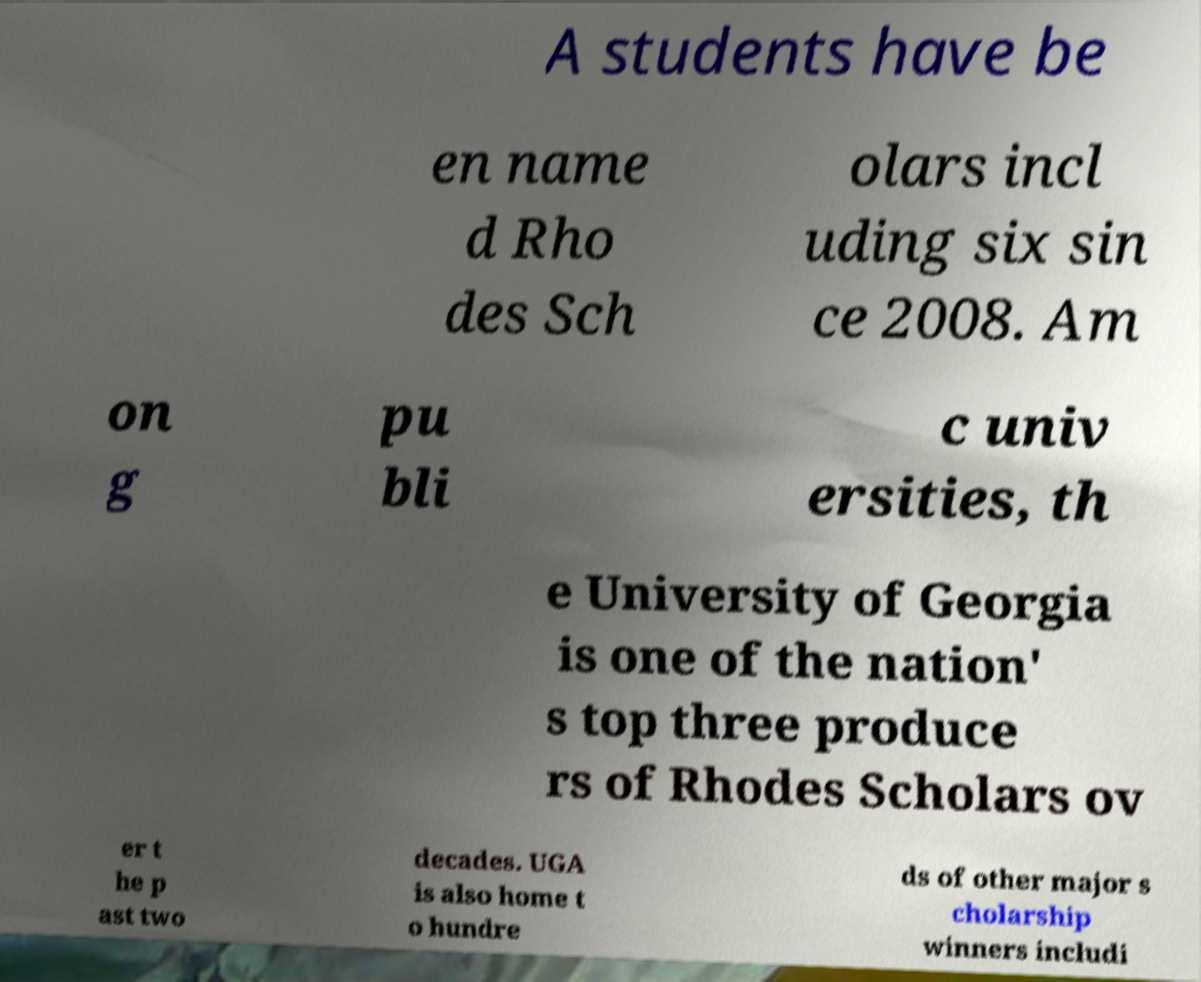For documentation purposes, I need the text within this image transcribed. Could you provide that? A students have be en name d Rho des Sch olars incl uding six sin ce 2008. Am on g pu bli c univ ersities, th e University of Georgia is one of the nation' s top three produce rs of Rhodes Scholars ov er t he p ast two decades. UGA is also home t o hundre ds of other major s cholarship winners includi 